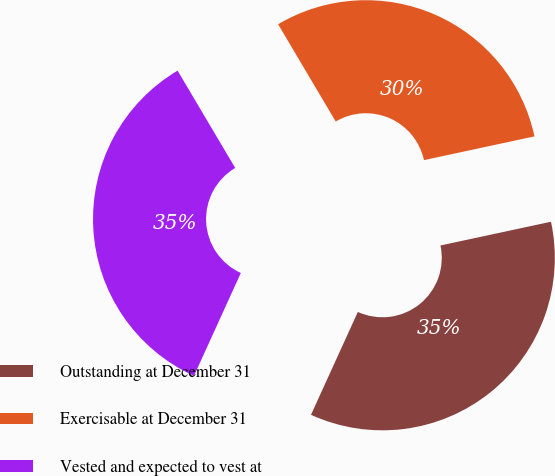Convert chart to OTSL. <chart><loc_0><loc_0><loc_500><loc_500><pie_chart><fcel>Outstanding at December 31<fcel>Exercisable at December 31<fcel>Vested and expected to vest at<nl><fcel>35.17%<fcel>30.14%<fcel>34.69%<nl></chart> 